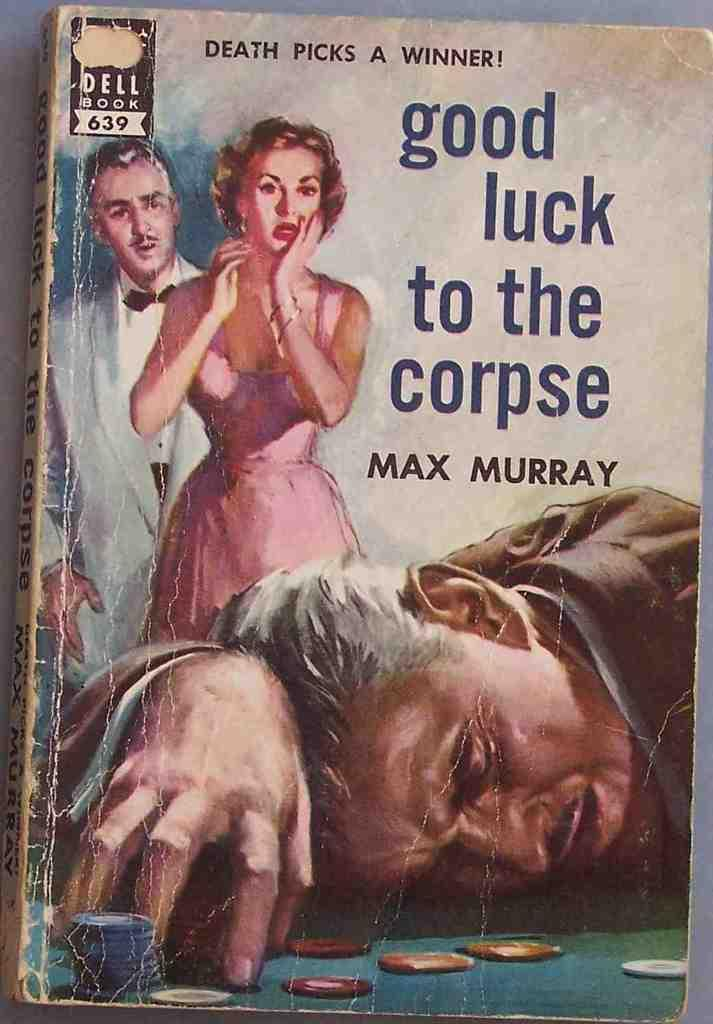<image>
Write a terse but informative summary of the picture. An old paperback book titled good luck to the corpse. 